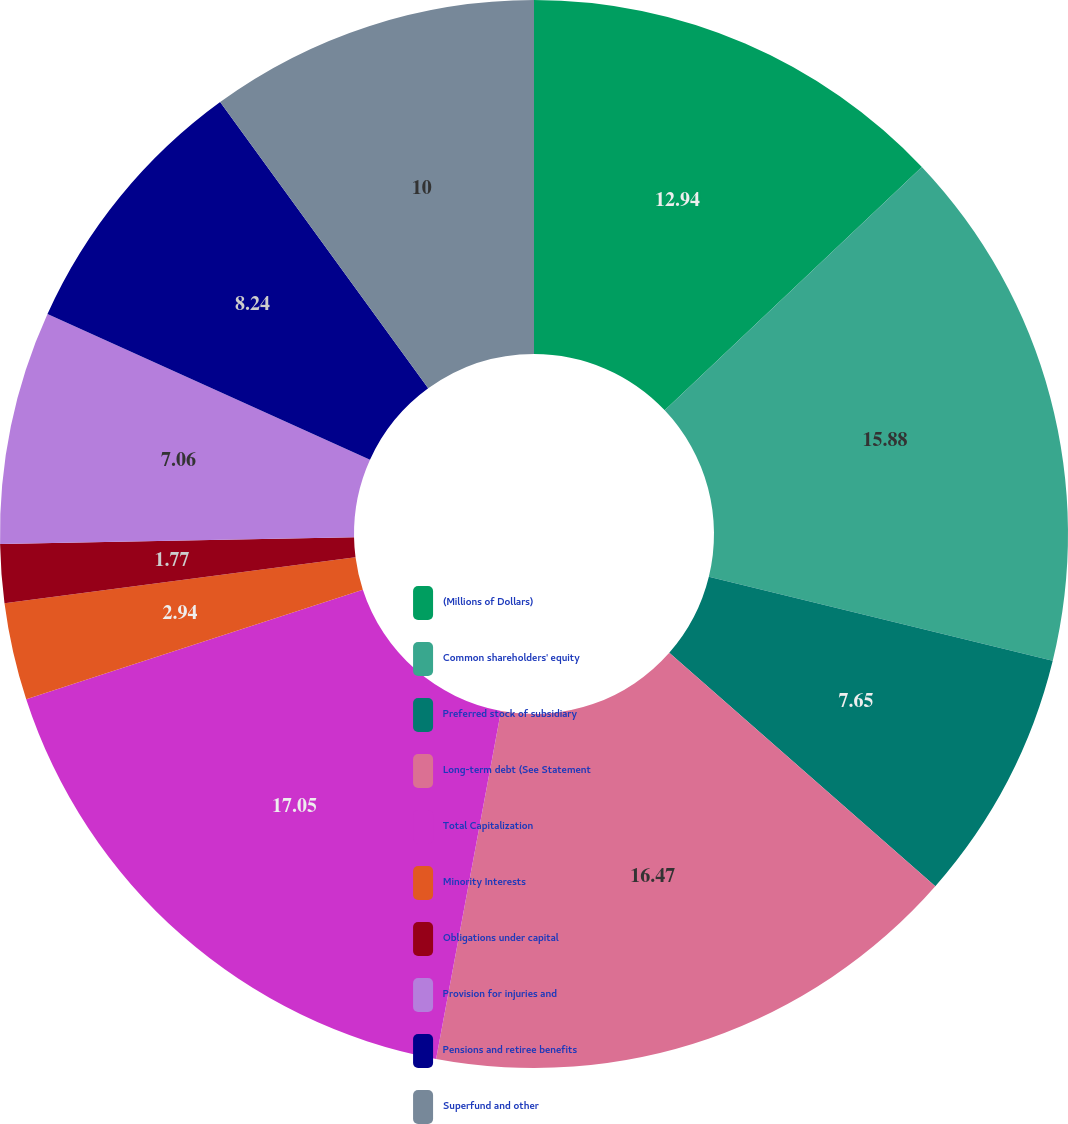Convert chart to OTSL. <chart><loc_0><loc_0><loc_500><loc_500><pie_chart><fcel>(Millions of Dollars)<fcel>Common shareholders' equity<fcel>Preferred stock of subsidiary<fcel>Long-term debt (See Statement<fcel>Total Capitalization<fcel>Minority Interests<fcel>Obligations under capital<fcel>Provision for injuries and<fcel>Pensions and retiree benefits<fcel>Superfund and other<nl><fcel>12.94%<fcel>15.88%<fcel>7.65%<fcel>16.47%<fcel>17.06%<fcel>2.94%<fcel>1.77%<fcel>7.06%<fcel>8.24%<fcel>10.0%<nl></chart> 